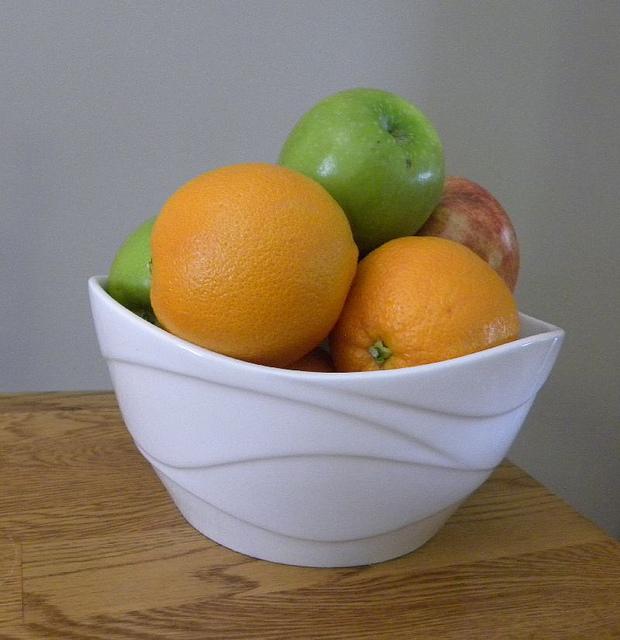What is the largest fruit at the bottom of the bowl?
Keep it brief. Orange. What is the bowl sitting on?
Be succinct. Table. What color is the bowl the fruit is in?
Quick response, please. White. Is the fruit rotten?
Write a very short answer. No. How many fruits are in the bowl?
Write a very short answer. 6. What number or oranges are in the bowl?
Keep it brief. 2. How many different fruits are pictured?
Keep it brief. 2. What color is the bowl?
Write a very short answer. White. How many limes?
Answer briefly. 0. What is the bowl probably made of?
Concise answer only. Ceramic. How many oranges are in the bowl?
Short answer required. 2. How many fruit are in the bowl?
Be succinct. 5. Would you call the bowl of fruit a miniature?
Concise answer only. No. Is this bowl glass or plastic?
Keep it brief. Glass. What kind of basket is it?
Be succinct. Fruit. How many dishes are there?
Quick response, please. 1. 